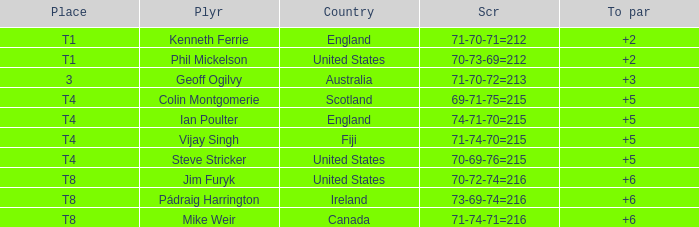What player was place of t1 in To Par and had a score of 70-73-69=212? 2.0. 